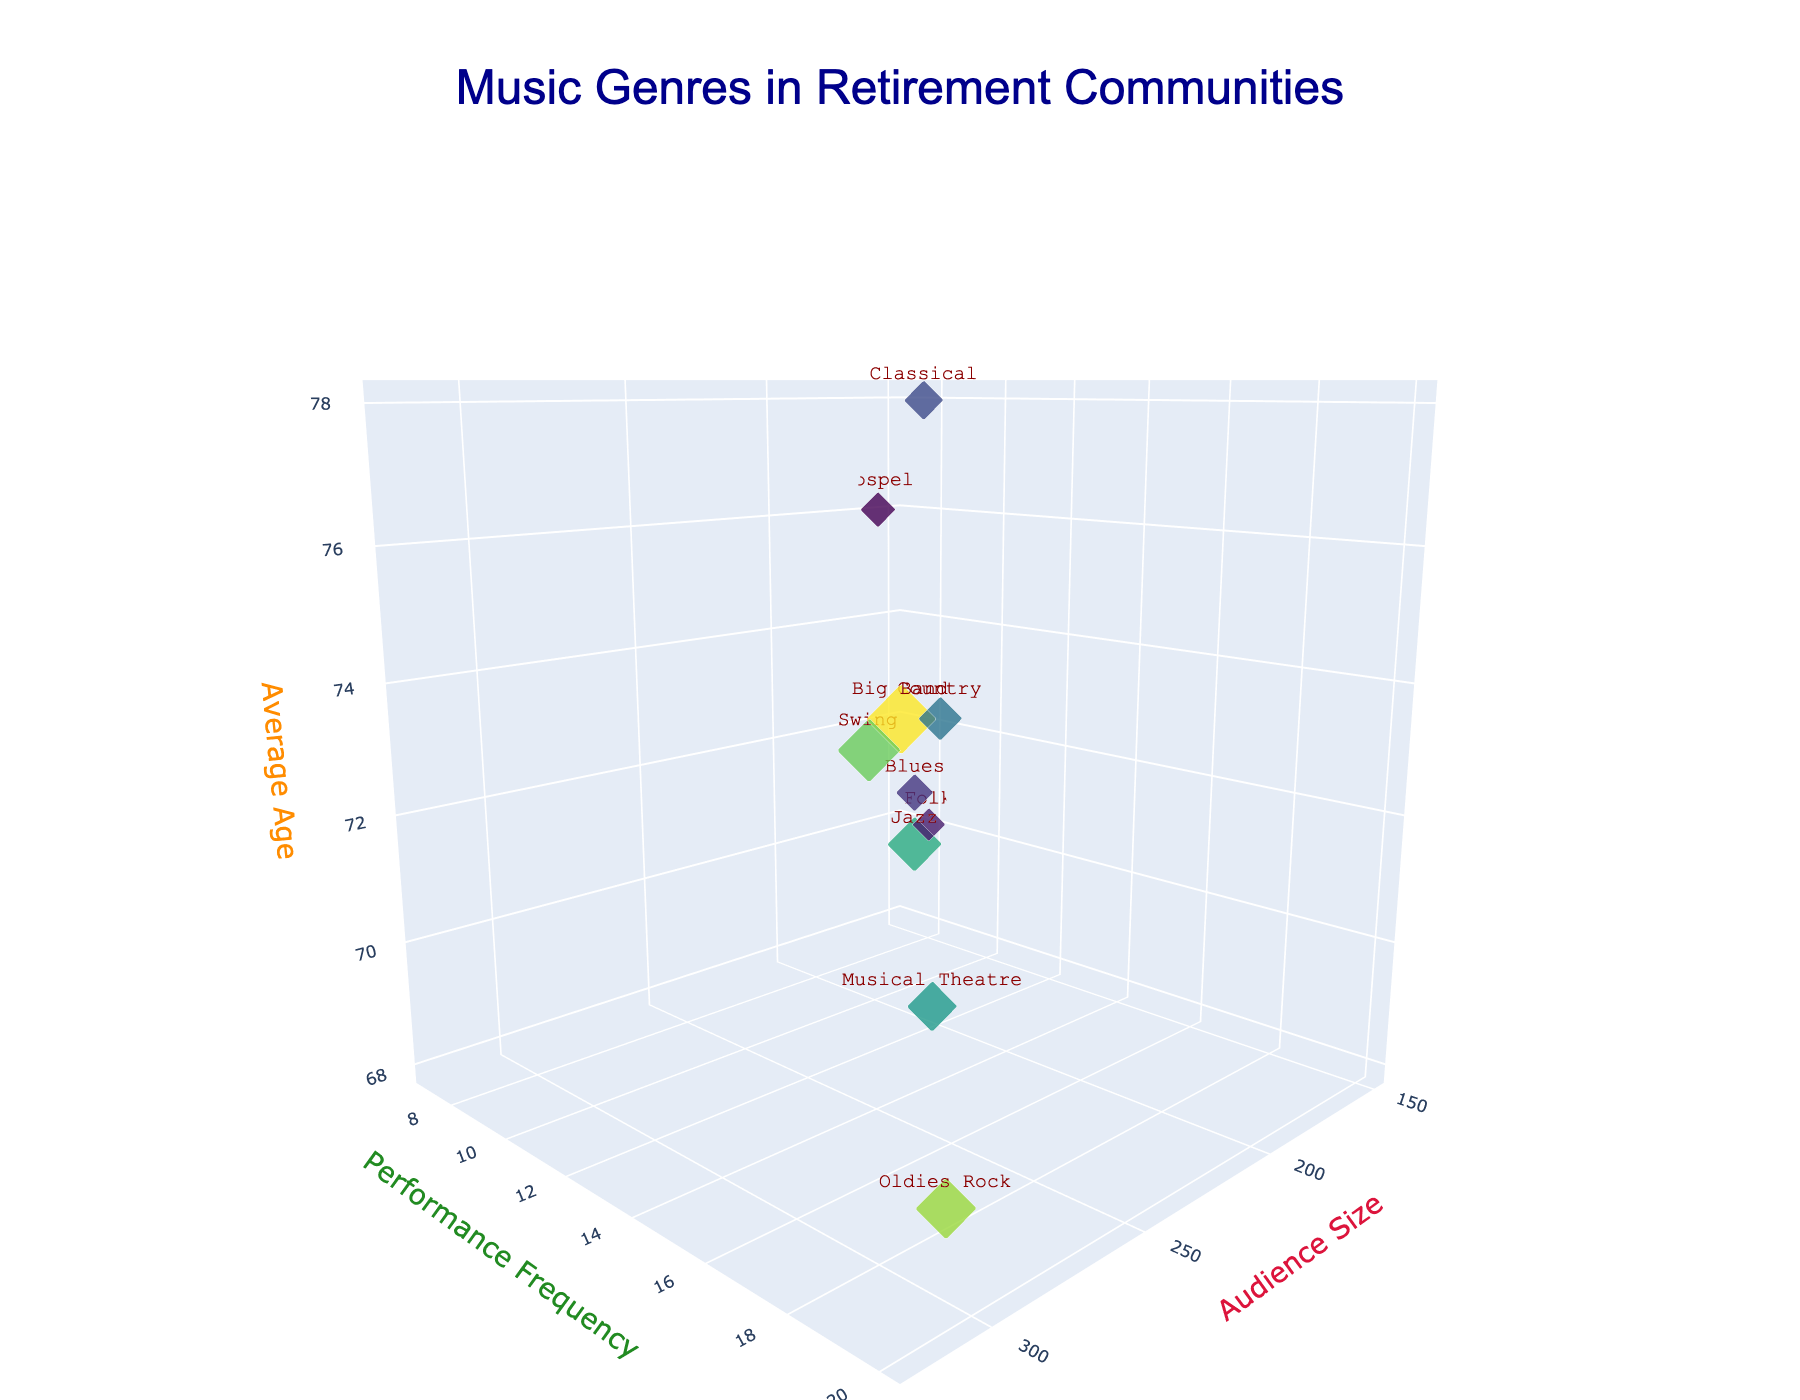What is the title of the 3D bubble chart? The title can be found at the top of the chart.
Answer: "Music Genres in Retirement Communities" Which genre has the largest audience size? Locate the largest bubble on the x-axis representing 'Audience Size.' The largest bubble should be marked with the genre's name.
Answer: Big Band How many music genres have a performance frequency above 15? Check the y-axis for 'Performance Frequency' and identify the number of genres with a y-value above 15.
Answer: 4 Arrange the genres Jazz, Classical, and Swing by audience size from smallest to largest. Compare the x-values ('Audience Size') of Jazz, Classical, and Swing and list them in ascending order.
Answer: Classical, Jazz, Swing Which genre caters to the oldest average audience age? Find the highest z-value ('Average Age') on the chart and identify the associated genre.
Answer: Classical Compare the audience size of the genres with an average age of 70 or below. Which one is the largest? Identify genres with a z-value ('Average Age') of 70 or below, and among them, find the one with the largest x-value ('Audience Size').
Answer: Oldies Rock Which genre has the smallest bubble size? The size of the bubble corresponds to the 'Audience Size' divided by 10. Identify the smallest bubble by comparing their sizes.
Answer: Folk How does the average age correlate with the audience size and performance frequency? Examine the correlation visually by observing the trends: 
1) See if larger bubbles (higher Audience Size) are placed at higher or lower z-values (Average Age).
2) Note if genres with high Performance Frequency (y-axis) also show a pattern with their z-values.
Answer: Generally, genres with higher performance frequency or larger audience sizes don't necessarily correlate with higher average age 